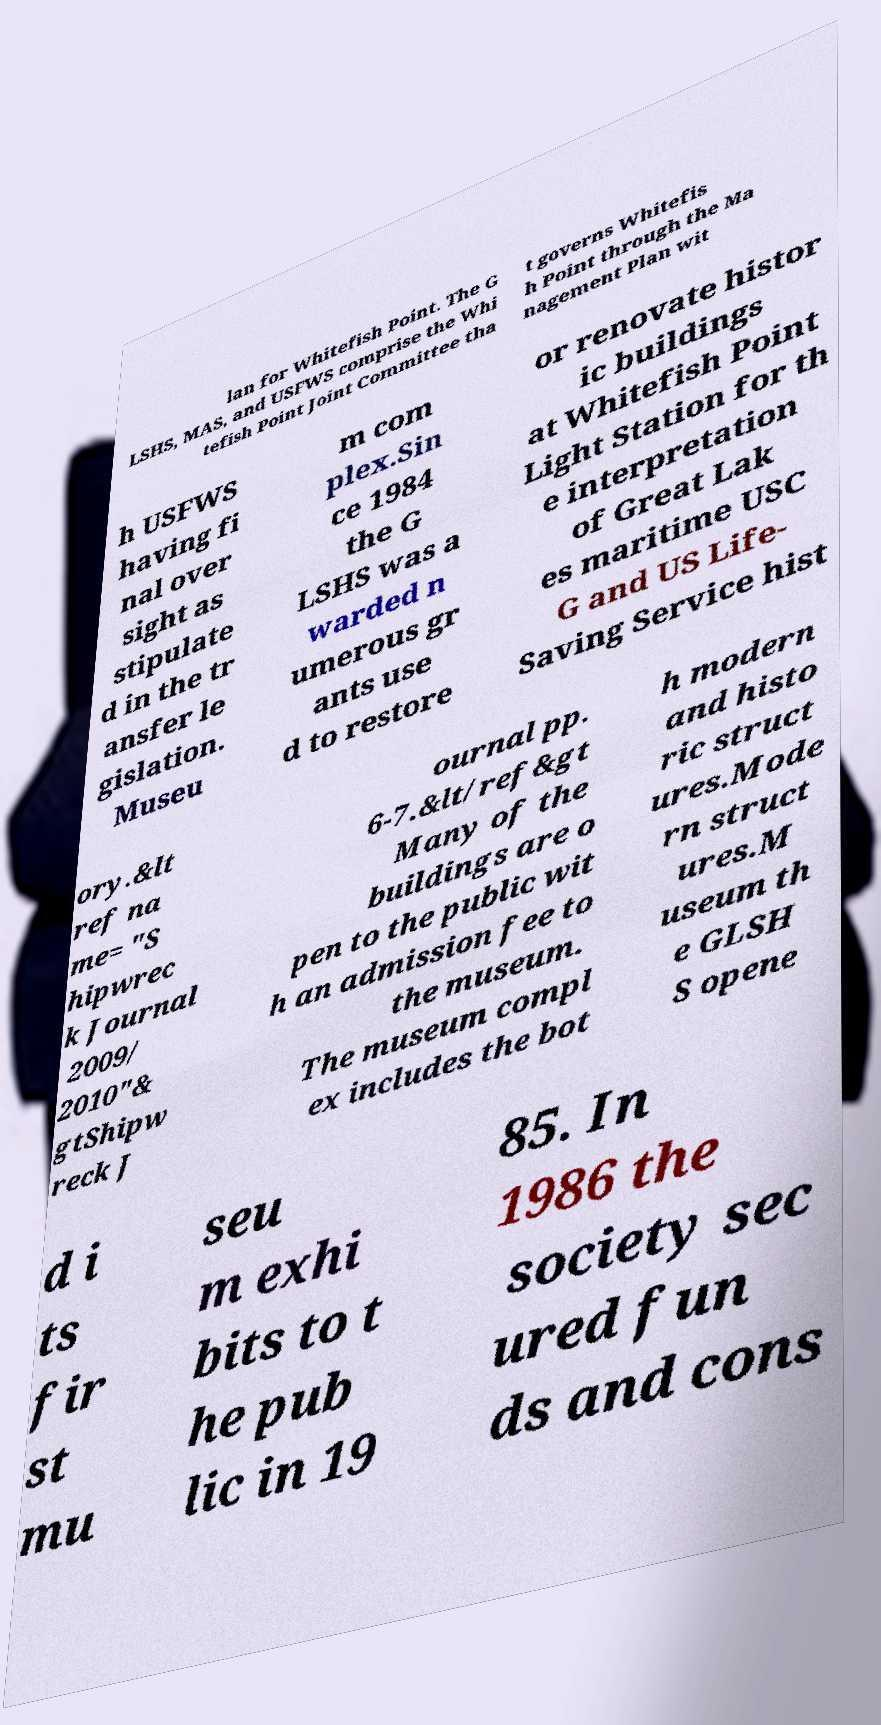Please read and relay the text visible in this image. What does it say? lan for Whitefish Point. The G LSHS, MAS, and USFWS comprise the Whi tefish Point Joint Committee tha t governs Whitefis h Point through the Ma nagement Plan wit h USFWS having fi nal over sight as stipulate d in the tr ansfer le gislation. Museu m com plex.Sin ce 1984 the G LSHS was a warded n umerous gr ants use d to restore or renovate histor ic buildings at Whitefish Point Light Station for th e interpretation of Great Lak es maritime USC G and US Life- Saving Service hist ory.&lt ref na me= "S hipwrec k Journal 2009/ 2010"& gtShipw reck J ournal pp. 6-7.&lt/ref&gt Many of the buildings are o pen to the public wit h an admission fee to the museum. The museum compl ex includes the bot h modern and histo ric struct ures.Mode rn struct ures.M useum th e GLSH S opene d i ts fir st mu seu m exhi bits to t he pub lic in 19 85. In 1986 the society sec ured fun ds and cons 